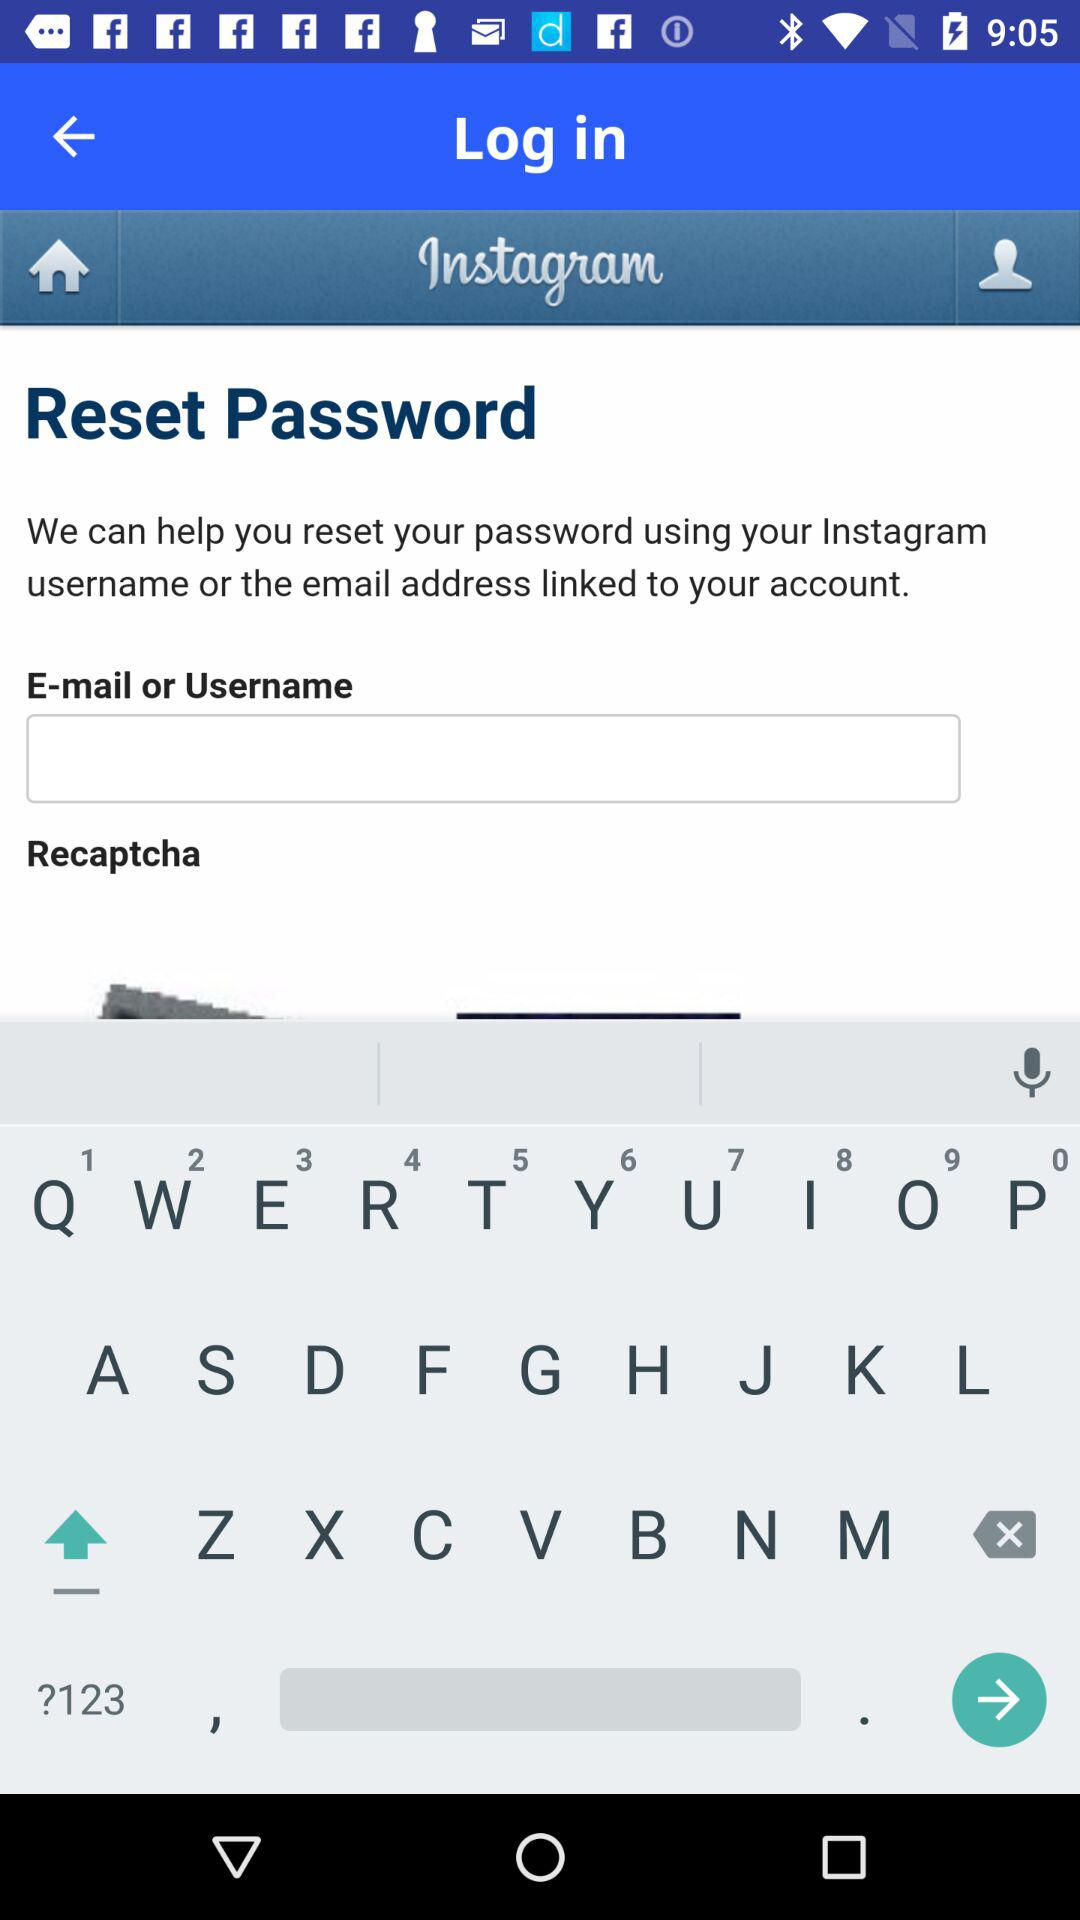What is the name of the application? The name of the application is "Instagram". 